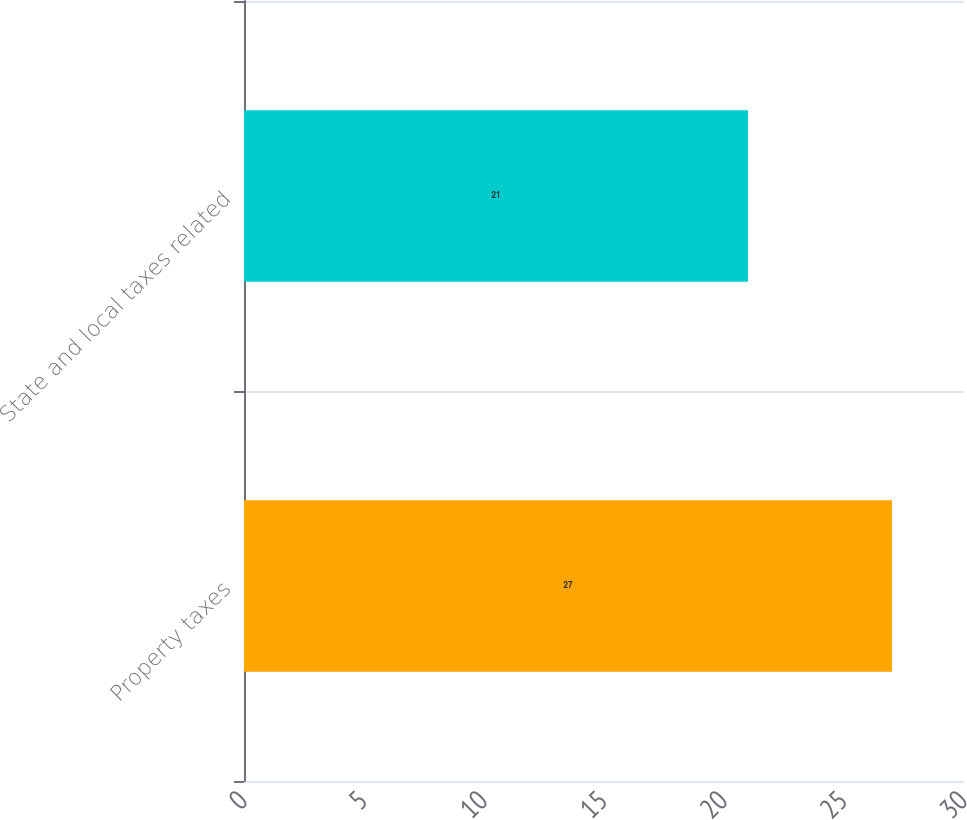Convert chart. <chart><loc_0><loc_0><loc_500><loc_500><bar_chart><fcel>Property taxes<fcel>State and local taxes related<nl><fcel>27<fcel>21<nl></chart> 